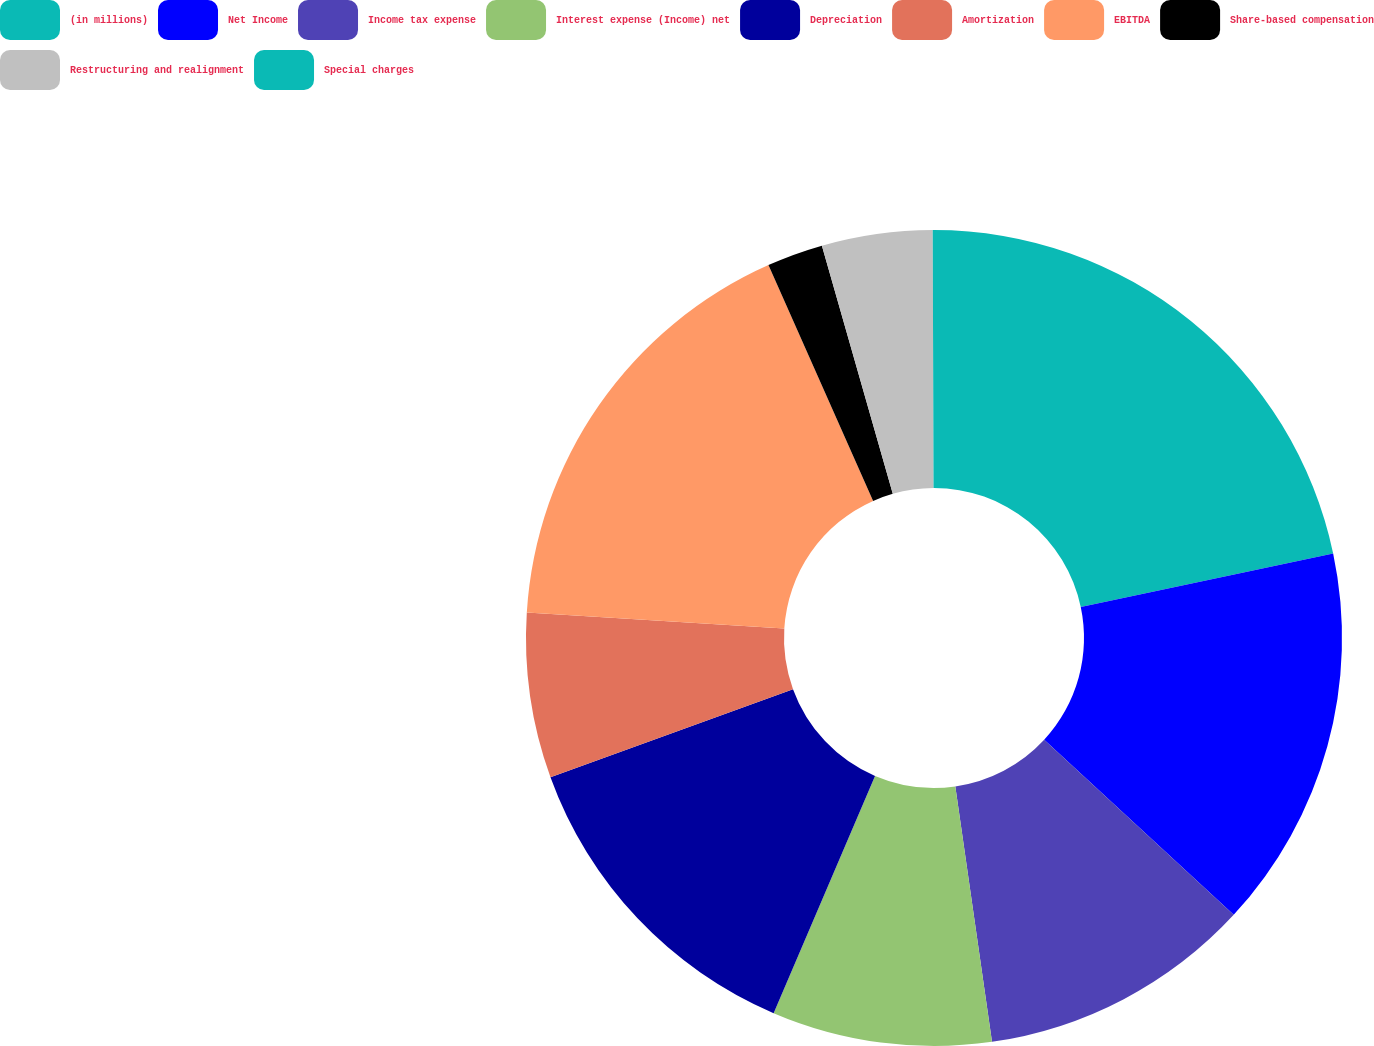<chart> <loc_0><loc_0><loc_500><loc_500><pie_chart><fcel>(in millions)<fcel>Net Income<fcel>Income tax expense<fcel>Interest expense (Income) net<fcel>Depreciation<fcel>Amortization<fcel>EBITDA<fcel>Share-based compensation<fcel>Restructuring and realignment<fcel>Special charges<nl><fcel>21.68%<fcel>15.19%<fcel>10.86%<fcel>8.7%<fcel>13.03%<fcel>6.54%<fcel>17.35%<fcel>2.22%<fcel>4.38%<fcel>0.05%<nl></chart> 